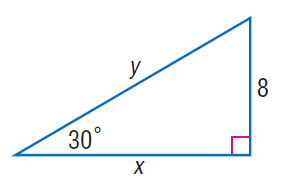Answer the mathemtical geometry problem and directly provide the correct option letter.
Question: Find x.
Choices: A: 8 B: 8 \sqrt { 3 } C: 16 D: 16 \sqrt { 3 } B 